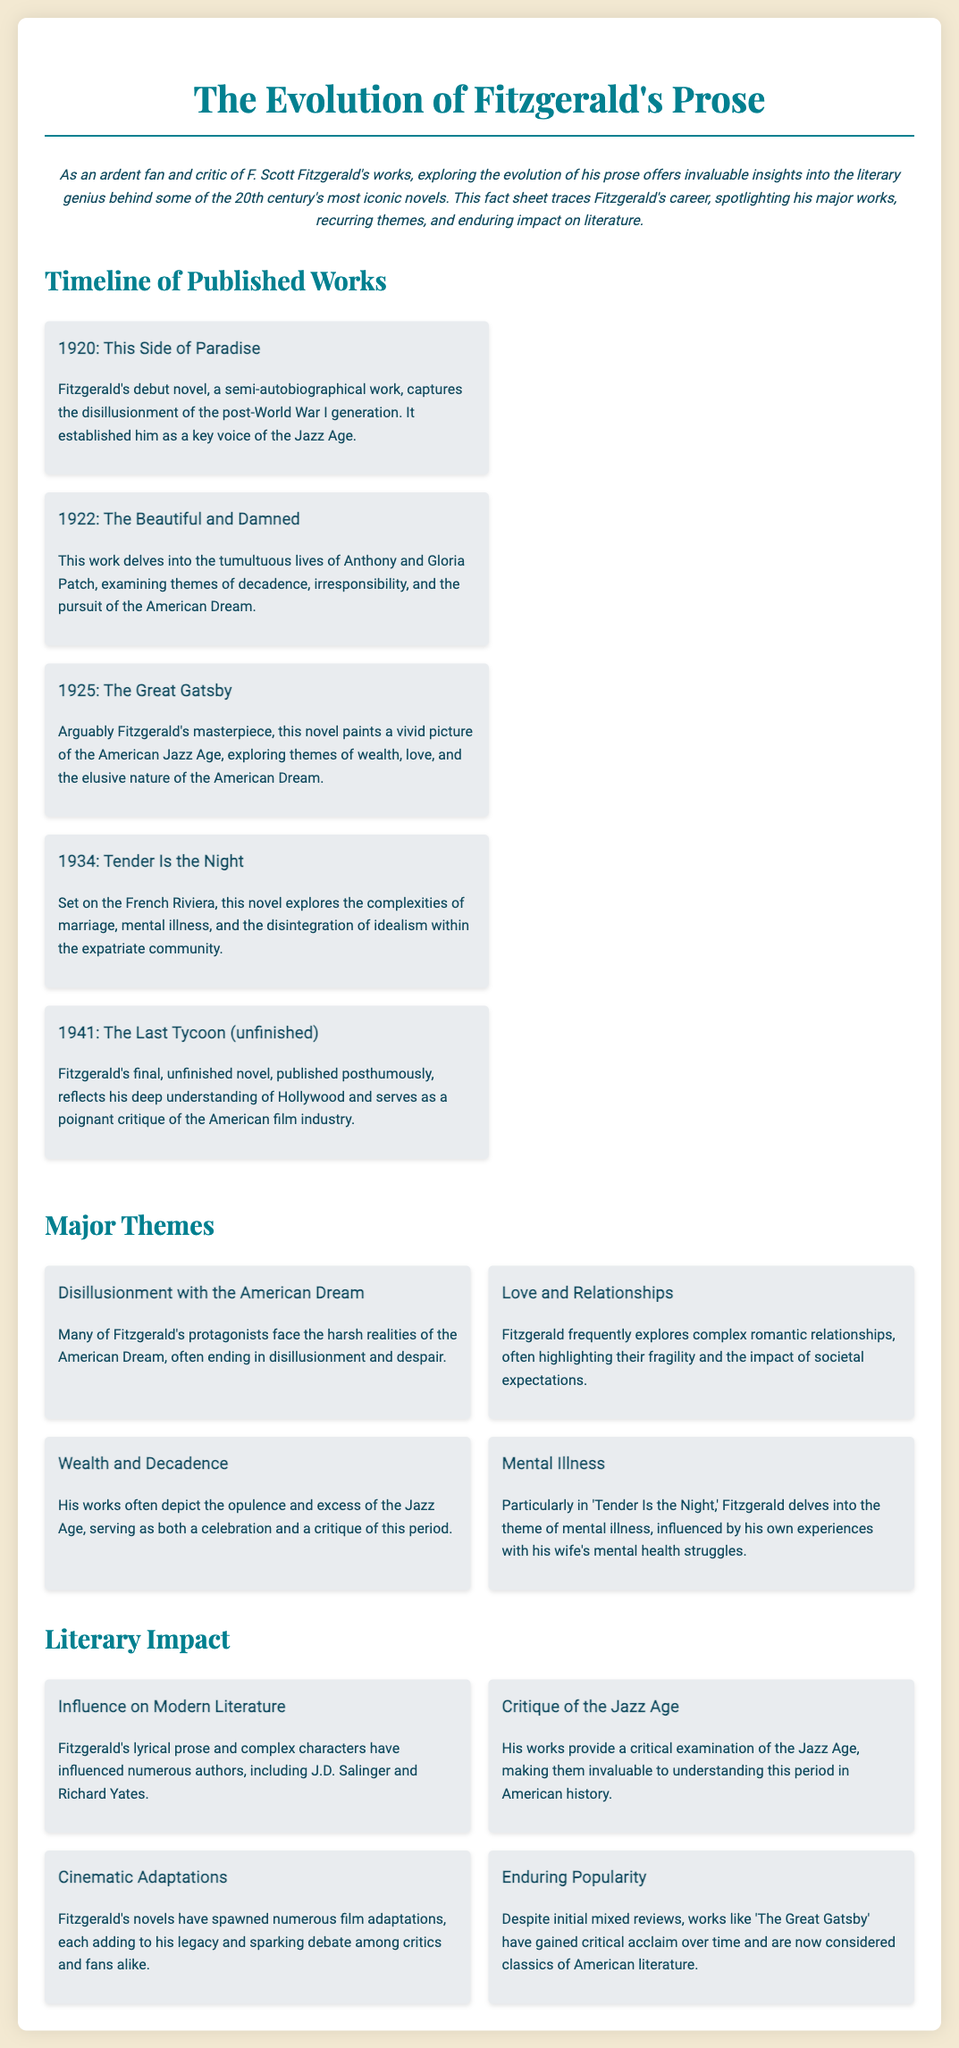what is the title of Fitzgerald's debut novel? The document states that Fitzgerald's debut novel is "This Side of Paradise."
Answer: This Side of Paradise in what year was The Great Gatsby published? The timeline indicates that "The Great Gatsby" was published in 1925.
Answer: 1925 what major theme focuses on the impact of societal expectations in relationships? The document describes "Love and Relationships" as a major theme that highlights the impact of societal expectations.
Answer: Love and Relationships which novel is noted for exploring mental illness? According to the document, "Tender Is the Night" delves into the theme of mental illness.
Answer: Tender Is the Night how many works are listed in the timeline? The timeline section features five works published by Fitzgerald.
Answer: Five who did Fitzgerald influence in modern literature? The document mentions that he influenced authors such as J.D. Salinger and Richard Yates.
Answer: J.D. Salinger and Richard Yates which work is described as Fitzgerald's masterpiece? The timeline indicates that "The Great Gatsby" is considered Fitzgerald's masterpiece.
Answer: The Great Gatsby what is a recurring theme in Fitzgerald's works related to the American Dream? The document indicates that many protagonists in Fitzgerald's works face "Disillusionment with the American Dream."
Answer: Disillusionment with the American Dream what does the document say about Fitzgerald's cinematic adaptations? It states that Fitzgerald's novels have spawned numerous film adaptations.
Answer: Numerous film adaptations 